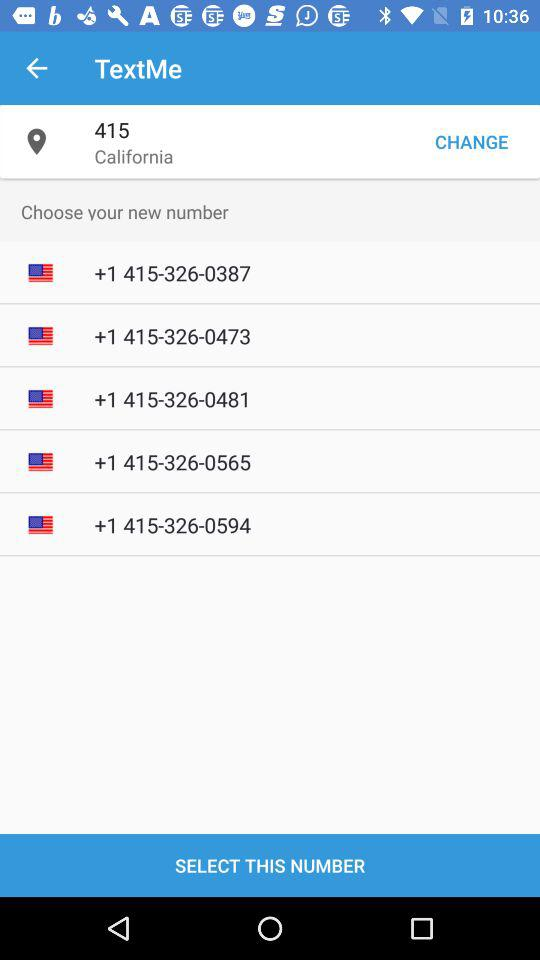What is the location? The location is California. 